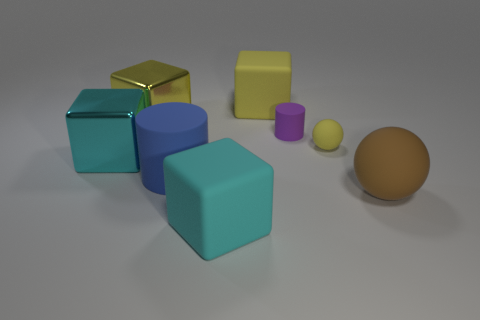What shape is the shiny object that is the same color as the tiny sphere?
Keep it short and to the point. Cube. Are there the same number of metallic things on the right side of the small yellow rubber thing and balls?
Your answer should be compact. No. How many matte cylinders are both to the right of the blue object and in front of the small purple thing?
Make the answer very short. 0. What is the size of the other object that is the same shape as the tiny yellow thing?
Ensure brevity in your answer.  Large. What number of big spheres have the same material as the tiny purple object?
Make the answer very short. 1. Is the number of tiny purple rubber cylinders in front of the large cyan rubber object less than the number of large yellow objects?
Your answer should be compact. Yes. What number of purple objects are there?
Keep it short and to the point. 1. How many cubes are the same color as the tiny matte sphere?
Ensure brevity in your answer.  2. Does the purple rubber object have the same shape as the large blue matte thing?
Offer a very short reply. Yes. There is a cyan cube that is behind the matte block that is in front of the large brown object; what is its size?
Your answer should be very brief. Large. 